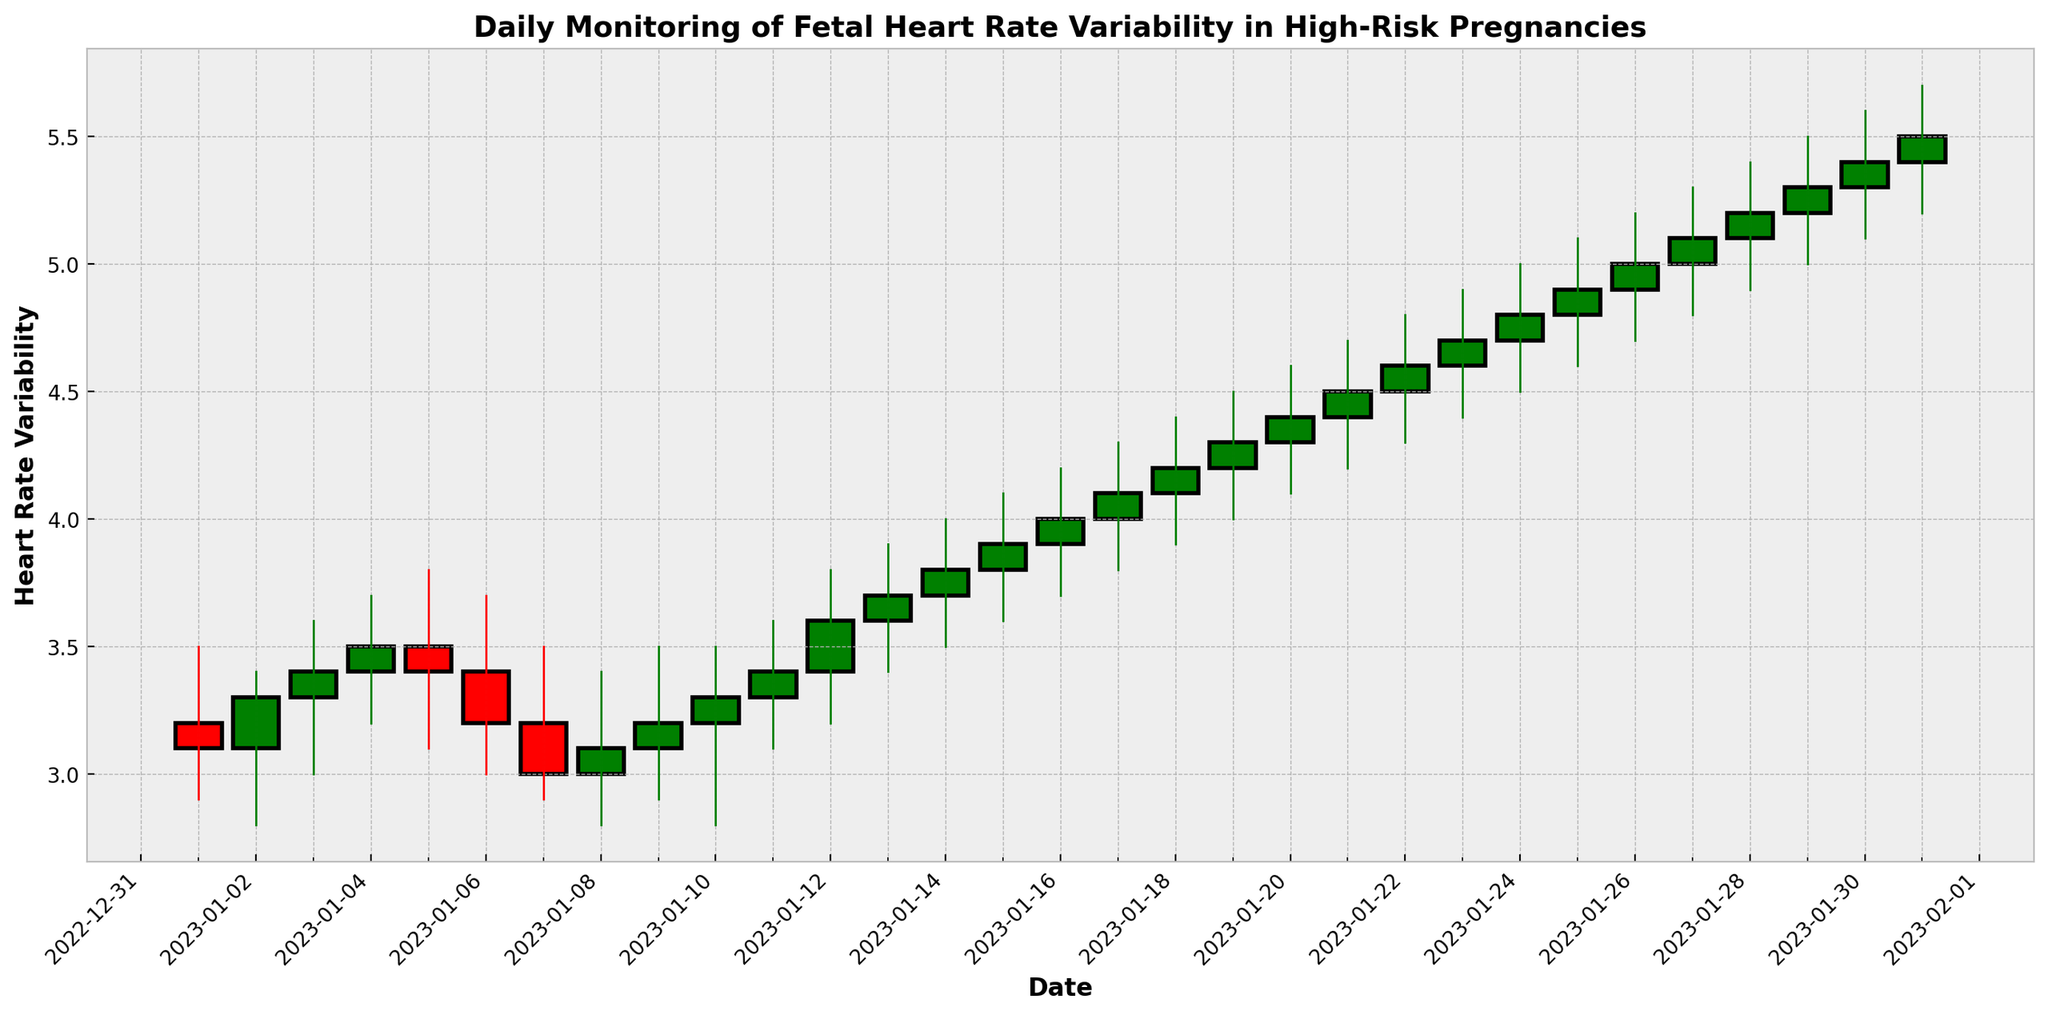What is the overall trend in fetal heart rate variability from January 1 to January 31? The overall trend is determined by observing whether the values are generally increasing or decreasing. From the chart, we see that the fetal heart rate variability starts around 3.2 and ends around 5.5, indicating an increasing trend.
Answer: Increasing trend Which day shows the highest peak in fetal heart rate variability? To identify the highest peak, look for the highest value in the "High" column in the chart, which corresponds to January 31 with a value of 5.7.
Answer: January 31 What is the difference in fetal heart rate variability between January 1 and January 31 close values? Calculate the difference between the close value of January 31 (5.5) and the close value of January 1 (3.1). So, 5.5 - 3.1 = 2.4.
Answer: 2.4 On which day does the fetal heart rate variability have the largest range? The range is calculated by finding the difference between the high and low values each day. January 31 has the largest range (5.7 - 5.2 = 0.5).
Answer: January 31 On how many days did the fetal heart rate variability decrease from open to close? Count the number of red rectangles in the chart, which indicate days where the close value is less than the open value. There are six such days (January 6, 7, 8, 26, 27, and 28).
Answer: 6 days How does the variability on January 1 compare to January 16? Compare the open, high, low, and close values for both days. January 1: 3.2, 3.5, 2.9, 3.1. January 16: 3.9, 4.2, 3.7, 4.0. All values are higher on January 16.
Answer: Higher on January 16 What is the average close value over the entire month? Sum all the close values and divide by the number of days. (3.1 + 3.3 + 3.4 + 3.5 + 3.4 + 3.2 + 3.0 + 3.1 + 3.2 + 3.3 + 3.4 + 3.6 + 3.7 + 3.8 + 3.9 + 4.0 + 4.1 + 4.2 + 4.3 + 4.4 + 4.5 + 4.6 + 4.7 + 4.8 + 4.9 + 5.0 + 5.1 + 5.2 + 5.3 + 5.4 + 5.5) / 31 = 4.0
Answer: 4.0 Which day had the largest drop in fetal heart rate variability? For each day, subtract the high value from the low value to find the daily drop. The largest drop is seen on January 31 (5.7 - 5.2 = 0.5).
Answer: January 31 